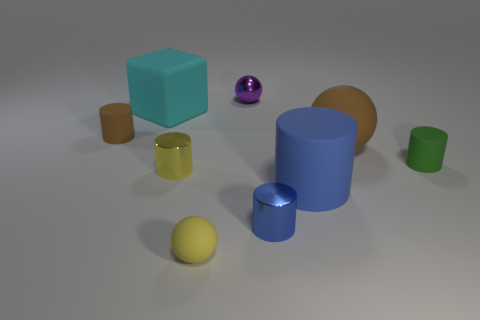There is a cylinder that is behind the big brown sphere; is its color the same as the large rubber sphere?
Offer a terse response. Yes. What number of blocks are either small brown things or large blue things?
Keep it short and to the point. 0. Are there any brown things that are in front of the small yellow metallic cylinder on the left side of the small purple thing?
Provide a succinct answer. No. Is there any other thing that has the same material as the yellow sphere?
Offer a very short reply. Yes. Is the shape of the tiny green rubber thing the same as the brown thing in front of the small brown matte thing?
Your answer should be compact. No. How many other objects are there of the same size as the green matte cylinder?
Ensure brevity in your answer.  5. What number of green objects are either matte cubes or large matte things?
Your response must be concise. 0. What number of spheres are to the right of the small yellow sphere and in front of the small yellow shiny cylinder?
Offer a very short reply. 0. There is a big thing that is in front of the tiny rubber cylinder to the right of the rubber thing that is behind the tiny brown matte cylinder; what is its material?
Offer a very short reply. Rubber. What number of yellow spheres have the same material as the big cyan cube?
Keep it short and to the point. 1. 